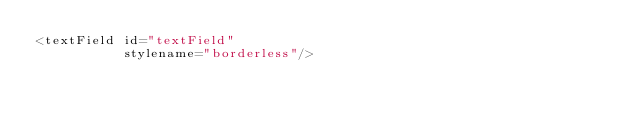Convert code to text. <code><loc_0><loc_0><loc_500><loc_500><_XML_><textField id="textField"
           stylename="borderless"/></code> 